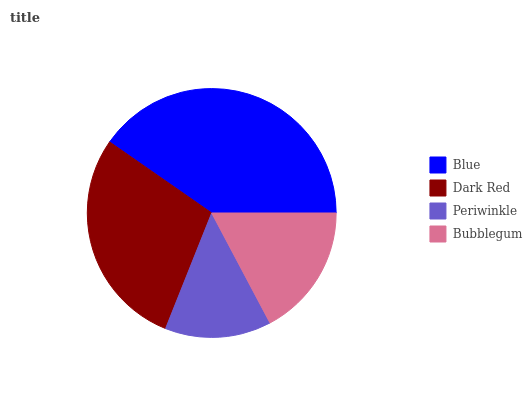Is Periwinkle the minimum?
Answer yes or no. Yes. Is Blue the maximum?
Answer yes or no. Yes. Is Dark Red the minimum?
Answer yes or no. No. Is Dark Red the maximum?
Answer yes or no. No. Is Blue greater than Dark Red?
Answer yes or no. Yes. Is Dark Red less than Blue?
Answer yes or no. Yes. Is Dark Red greater than Blue?
Answer yes or no. No. Is Blue less than Dark Red?
Answer yes or no. No. Is Dark Red the high median?
Answer yes or no. Yes. Is Bubblegum the low median?
Answer yes or no. Yes. Is Bubblegum the high median?
Answer yes or no. No. Is Periwinkle the low median?
Answer yes or no. No. 